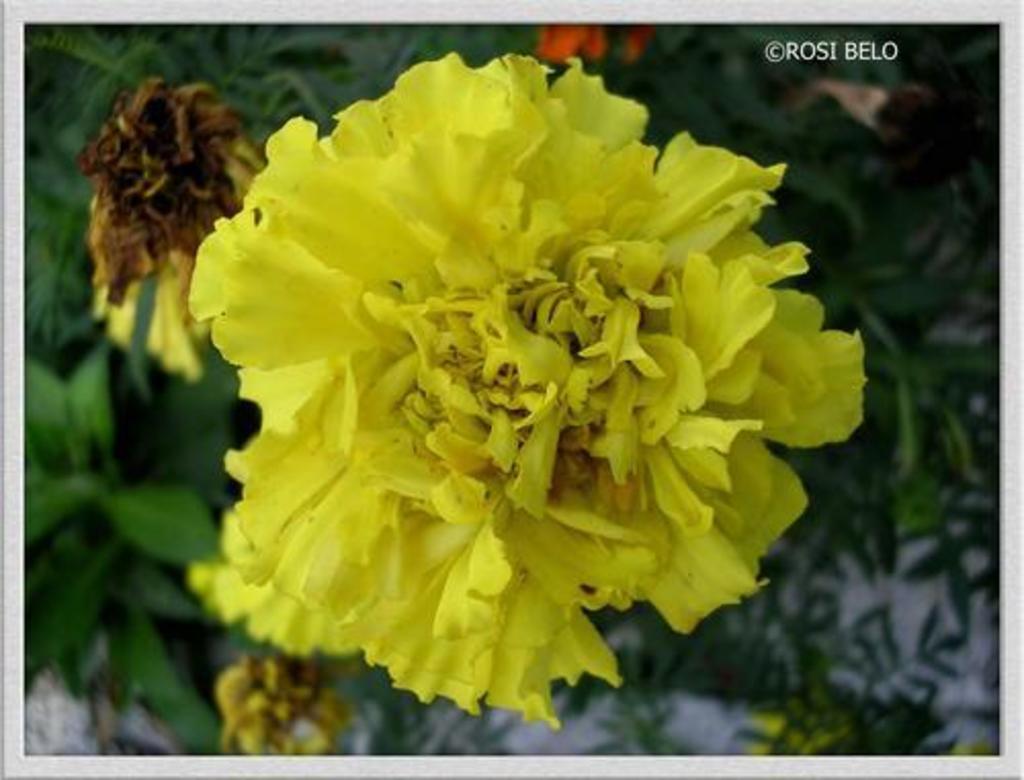Could you give a brief overview of what you see in this image? This picture shows plants and we see few flowers and a flower is yellow in color and we see a watermark on the top right corner. 